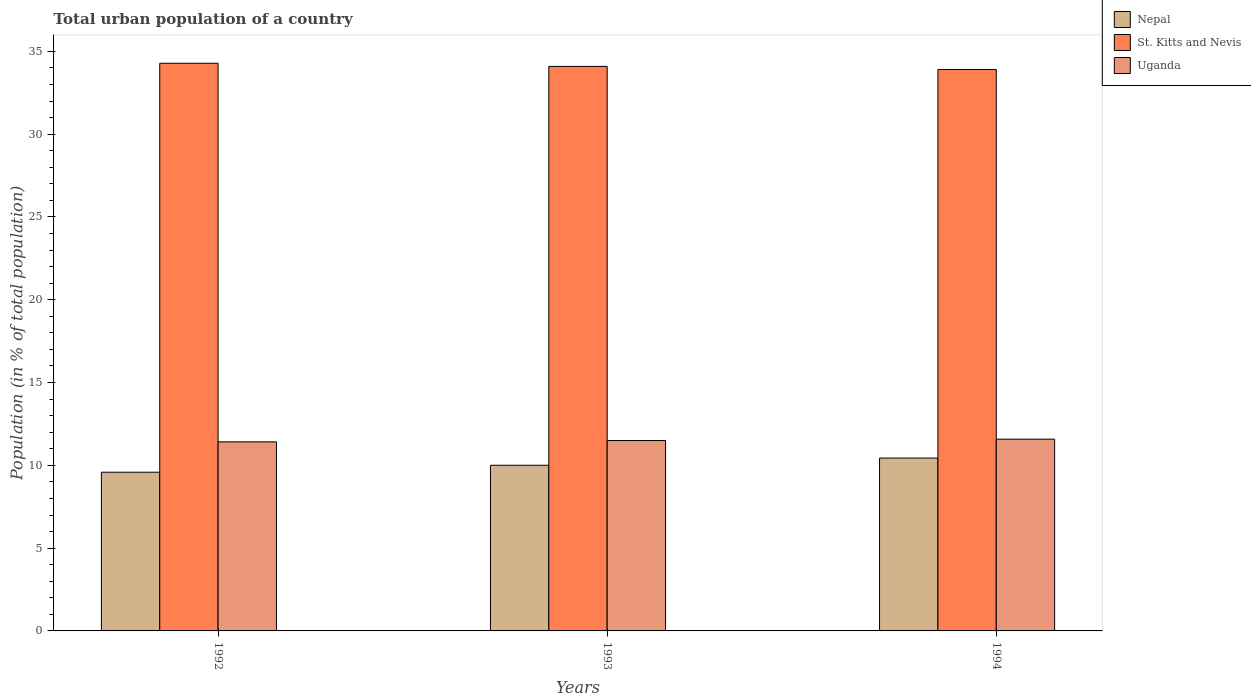How many groups of bars are there?
Offer a very short reply. 3. Are the number of bars on each tick of the X-axis equal?
Your answer should be very brief. Yes. How many bars are there on the 2nd tick from the left?
Keep it short and to the point. 3. In how many cases, is the number of bars for a given year not equal to the number of legend labels?
Give a very brief answer. 0. What is the urban population in Uganda in 1994?
Give a very brief answer. 11.58. Across all years, what is the maximum urban population in Uganda?
Offer a terse response. 11.58. Across all years, what is the minimum urban population in Nepal?
Your response must be concise. 9.59. What is the total urban population in St. Kitts and Nevis in the graph?
Offer a terse response. 102.28. What is the difference between the urban population in St. Kitts and Nevis in 1992 and that in 1994?
Give a very brief answer. 0.38. What is the difference between the urban population in Nepal in 1992 and the urban population in St. Kitts and Nevis in 1993?
Provide a short and direct response. -24.51. What is the average urban population in Uganda per year?
Your answer should be compact. 11.5. In the year 1992, what is the difference between the urban population in Nepal and urban population in St. Kitts and Nevis?
Your answer should be very brief. -24.7. What is the ratio of the urban population in Nepal in 1992 to that in 1993?
Your answer should be compact. 0.96. Is the urban population in Uganda in 1992 less than that in 1994?
Keep it short and to the point. Yes. Is the difference between the urban population in Nepal in 1992 and 1994 greater than the difference between the urban population in St. Kitts and Nevis in 1992 and 1994?
Make the answer very short. No. What is the difference between the highest and the second highest urban population in Uganda?
Offer a terse response. 0.08. What is the difference between the highest and the lowest urban population in Uganda?
Offer a terse response. 0.16. What does the 3rd bar from the left in 1994 represents?
Your answer should be compact. Uganda. What does the 3rd bar from the right in 1994 represents?
Provide a succinct answer. Nepal. Is it the case that in every year, the sum of the urban population in Nepal and urban population in Uganda is greater than the urban population in St. Kitts and Nevis?
Keep it short and to the point. No. How many bars are there?
Ensure brevity in your answer.  9. Are all the bars in the graph horizontal?
Provide a short and direct response. No. What is the difference between two consecutive major ticks on the Y-axis?
Provide a succinct answer. 5. Does the graph contain any zero values?
Your answer should be compact. No. Does the graph contain grids?
Keep it short and to the point. No. What is the title of the graph?
Your answer should be very brief. Total urban population of a country. Does "Spain" appear as one of the legend labels in the graph?
Your answer should be very brief. No. What is the label or title of the Y-axis?
Provide a short and direct response. Population (in % of total population). What is the Population (in % of total population) of Nepal in 1992?
Provide a succinct answer. 9.59. What is the Population (in % of total population) of St. Kitts and Nevis in 1992?
Provide a succinct answer. 34.28. What is the Population (in % of total population) of Uganda in 1992?
Keep it short and to the point. 11.42. What is the Population (in % of total population) in Nepal in 1993?
Your response must be concise. 10.01. What is the Population (in % of total population) of St. Kitts and Nevis in 1993?
Give a very brief answer. 34.09. What is the Population (in % of total population) in Uganda in 1993?
Make the answer very short. 11.5. What is the Population (in % of total population) in Nepal in 1994?
Provide a short and direct response. 10.44. What is the Population (in % of total population) of St. Kitts and Nevis in 1994?
Offer a terse response. 33.9. What is the Population (in % of total population) in Uganda in 1994?
Provide a short and direct response. 11.58. Across all years, what is the maximum Population (in % of total population) of Nepal?
Your answer should be very brief. 10.44. Across all years, what is the maximum Population (in % of total population) of St. Kitts and Nevis?
Keep it short and to the point. 34.28. Across all years, what is the maximum Population (in % of total population) in Uganda?
Offer a very short reply. 11.58. Across all years, what is the minimum Population (in % of total population) of Nepal?
Make the answer very short. 9.59. Across all years, what is the minimum Population (in % of total population) in St. Kitts and Nevis?
Provide a short and direct response. 33.9. Across all years, what is the minimum Population (in % of total population) of Uganda?
Keep it short and to the point. 11.42. What is the total Population (in % of total population) in Nepal in the graph?
Your response must be concise. 30.03. What is the total Population (in % of total population) of St. Kitts and Nevis in the graph?
Your answer should be compact. 102.28. What is the total Population (in % of total population) of Uganda in the graph?
Provide a succinct answer. 34.5. What is the difference between the Population (in % of total population) of Nepal in 1992 and that in 1993?
Your response must be concise. -0.42. What is the difference between the Population (in % of total population) of St. Kitts and Nevis in 1992 and that in 1993?
Your answer should be very brief. 0.19. What is the difference between the Population (in % of total population) in Uganda in 1992 and that in 1993?
Offer a terse response. -0.08. What is the difference between the Population (in % of total population) in Nepal in 1992 and that in 1994?
Offer a very short reply. -0.86. What is the difference between the Population (in % of total population) of St. Kitts and Nevis in 1992 and that in 1994?
Offer a very short reply. 0.38. What is the difference between the Population (in % of total population) of Uganda in 1992 and that in 1994?
Ensure brevity in your answer.  -0.16. What is the difference between the Population (in % of total population) of Nepal in 1993 and that in 1994?
Your answer should be very brief. -0.44. What is the difference between the Population (in % of total population) of St. Kitts and Nevis in 1993 and that in 1994?
Provide a succinct answer. 0.19. What is the difference between the Population (in % of total population) in Uganda in 1993 and that in 1994?
Provide a succinct answer. -0.08. What is the difference between the Population (in % of total population) in Nepal in 1992 and the Population (in % of total population) in St. Kitts and Nevis in 1993?
Ensure brevity in your answer.  -24.51. What is the difference between the Population (in % of total population) in Nepal in 1992 and the Population (in % of total population) in Uganda in 1993?
Provide a short and direct response. -1.91. What is the difference between the Population (in % of total population) in St. Kitts and Nevis in 1992 and the Population (in % of total population) in Uganda in 1993?
Your answer should be very brief. 22.78. What is the difference between the Population (in % of total population) of Nepal in 1992 and the Population (in % of total population) of St. Kitts and Nevis in 1994?
Make the answer very short. -24.32. What is the difference between the Population (in % of total population) in Nepal in 1992 and the Population (in % of total population) in Uganda in 1994?
Offer a very short reply. -2. What is the difference between the Population (in % of total population) of St. Kitts and Nevis in 1992 and the Population (in % of total population) of Uganda in 1994?
Make the answer very short. 22.7. What is the difference between the Population (in % of total population) of Nepal in 1993 and the Population (in % of total population) of St. Kitts and Nevis in 1994?
Make the answer very short. -23.9. What is the difference between the Population (in % of total population) of Nepal in 1993 and the Population (in % of total population) of Uganda in 1994?
Ensure brevity in your answer.  -1.58. What is the difference between the Population (in % of total population) of St. Kitts and Nevis in 1993 and the Population (in % of total population) of Uganda in 1994?
Provide a succinct answer. 22.51. What is the average Population (in % of total population) in Nepal per year?
Provide a succinct answer. 10.01. What is the average Population (in % of total population) in St. Kitts and Nevis per year?
Your response must be concise. 34.09. What is the average Population (in % of total population) of Uganda per year?
Make the answer very short. 11.5. In the year 1992, what is the difference between the Population (in % of total population) of Nepal and Population (in % of total population) of St. Kitts and Nevis?
Your response must be concise. -24.7. In the year 1992, what is the difference between the Population (in % of total population) in Nepal and Population (in % of total population) in Uganda?
Give a very brief answer. -1.83. In the year 1992, what is the difference between the Population (in % of total population) in St. Kitts and Nevis and Population (in % of total population) in Uganda?
Provide a succinct answer. 22.86. In the year 1993, what is the difference between the Population (in % of total population) of Nepal and Population (in % of total population) of St. Kitts and Nevis?
Make the answer very short. -24.09. In the year 1993, what is the difference between the Population (in % of total population) in Nepal and Population (in % of total population) in Uganda?
Provide a short and direct response. -1.49. In the year 1993, what is the difference between the Population (in % of total population) in St. Kitts and Nevis and Population (in % of total population) in Uganda?
Provide a succinct answer. 22.59. In the year 1994, what is the difference between the Population (in % of total population) of Nepal and Population (in % of total population) of St. Kitts and Nevis?
Offer a very short reply. -23.46. In the year 1994, what is the difference between the Population (in % of total population) of Nepal and Population (in % of total population) of Uganda?
Provide a short and direct response. -1.14. In the year 1994, what is the difference between the Population (in % of total population) in St. Kitts and Nevis and Population (in % of total population) in Uganda?
Provide a succinct answer. 22.32. What is the ratio of the Population (in % of total population) in Nepal in 1992 to that in 1993?
Your answer should be compact. 0.96. What is the ratio of the Population (in % of total population) of St. Kitts and Nevis in 1992 to that in 1993?
Give a very brief answer. 1.01. What is the ratio of the Population (in % of total population) of Nepal in 1992 to that in 1994?
Offer a terse response. 0.92. What is the ratio of the Population (in % of total population) of St. Kitts and Nevis in 1992 to that in 1994?
Offer a terse response. 1.01. What is the ratio of the Population (in % of total population) in Uganda in 1992 to that in 1994?
Ensure brevity in your answer.  0.99. What is the ratio of the Population (in % of total population) in Nepal in 1993 to that in 1994?
Offer a terse response. 0.96. What is the ratio of the Population (in % of total population) in St. Kitts and Nevis in 1993 to that in 1994?
Offer a very short reply. 1.01. What is the ratio of the Population (in % of total population) of Uganda in 1993 to that in 1994?
Provide a succinct answer. 0.99. What is the difference between the highest and the second highest Population (in % of total population) in Nepal?
Your answer should be compact. 0.44. What is the difference between the highest and the second highest Population (in % of total population) of St. Kitts and Nevis?
Your answer should be compact. 0.19. What is the difference between the highest and the second highest Population (in % of total population) in Uganda?
Offer a very short reply. 0.08. What is the difference between the highest and the lowest Population (in % of total population) of Nepal?
Keep it short and to the point. 0.86. What is the difference between the highest and the lowest Population (in % of total population) in St. Kitts and Nevis?
Keep it short and to the point. 0.38. What is the difference between the highest and the lowest Population (in % of total population) in Uganda?
Give a very brief answer. 0.16. 